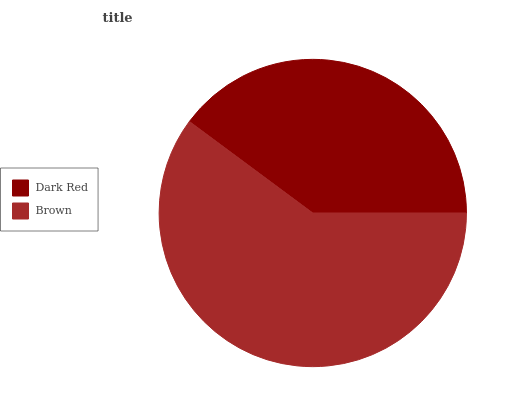Is Dark Red the minimum?
Answer yes or no. Yes. Is Brown the maximum?
Answer yes or no. Yes. Is Brown the minimum?
Answer yes or no. No. Is Brown greater than Dark Red?
Answer yes or no. Yes. Is Dark Red less than Brown?
Answer yes or no. Yes. Is Dark Red greater than Brown?
Answer yes or no. No. Is Brown less than Dark Red?
Answer yes or no. No. Is Brown the high median?
Answer yes or no. Yes. Is Dark Red the low median?
Answer yes or no. Yes. Is Dark Red the high median?
Answer yes or no. No. Is Brown the low median?
Answer yes or no. No. 